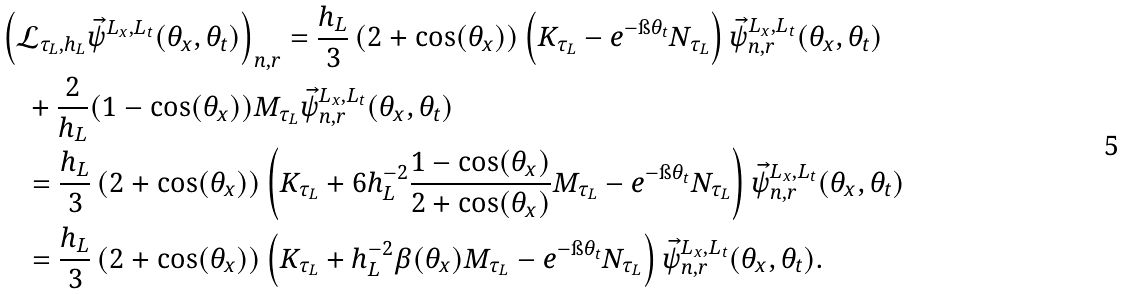<formula> <loc_0><loc_0><loc_500><loc_500>& \left ( \mathcal { L } _ { \tau _ { L } , h _ { L } } \vec { \psi } ^ { L _ { x } , L _ { t } } ( \theta _ { x } , \theta _ { t } ) \right ) _ { n , r } = \frac { h _ { L } } { 3 } \left ( 2 + \cos ( \theta _ { x } ) \right ) \left ( K _ { \tau _ { L } } - e ^ { - \i \theta _ { t } } N _ { \tau _ { L } } \right ) \vec { \psi } _ { n , r } ^ { L _ { x } , L _ { t } } ( \theta _ { x } , \theta _ { t } ) \\ & \quad + \frac { 2 } { h _ { L } } ( 1 - \cos ( \theta _ { x } ) ) M _ { \tau _ { L } } \vec { \psi } _ { n , r } ^ { L _ { x } , L _ { t } } ( \theta _ { x } , \theta _ { t } ) \\ & \quad = \frac { h _ { L } } { 3 } \left ( 2 + \cos ( \theta _ { x } ) \right ) \left ( K _ { \tau _ { L } } + 6 h _ { L } ^ { - 2 } \frac { 1 - \cos ( \theta _ { x } ) } { 2 + \cos ( \theta _ { x } ) } M _ { \tau _ { L } } - e ^ { - \i \theta _ { t } } N _ { \tau _ { L } } \right ) \vec { \psi } _ { n , r } ^ { L _ { x } , L _ { t } } ( \theta _ { x } , \theta _ { t } ) \\ & \quad = \frac { h _ { L } } { 3 } \left ( 2 + \cos ( \theta _ { x } ) \right ) \left ( K _ { \tau _ { L } } + h _ { L } ^ { - 2 } \beta ( \theta _ { x } ) M _ { \tau _ { L } } - e ^ { - \i \theta _ { t } } N _ { \tau _ { L } } \right ) \vec { \psi } _ { n , r } ^ { L _ { x } , L _ { t } } ( \theta _ { x } , \theta _ { t } ) .</formula> 